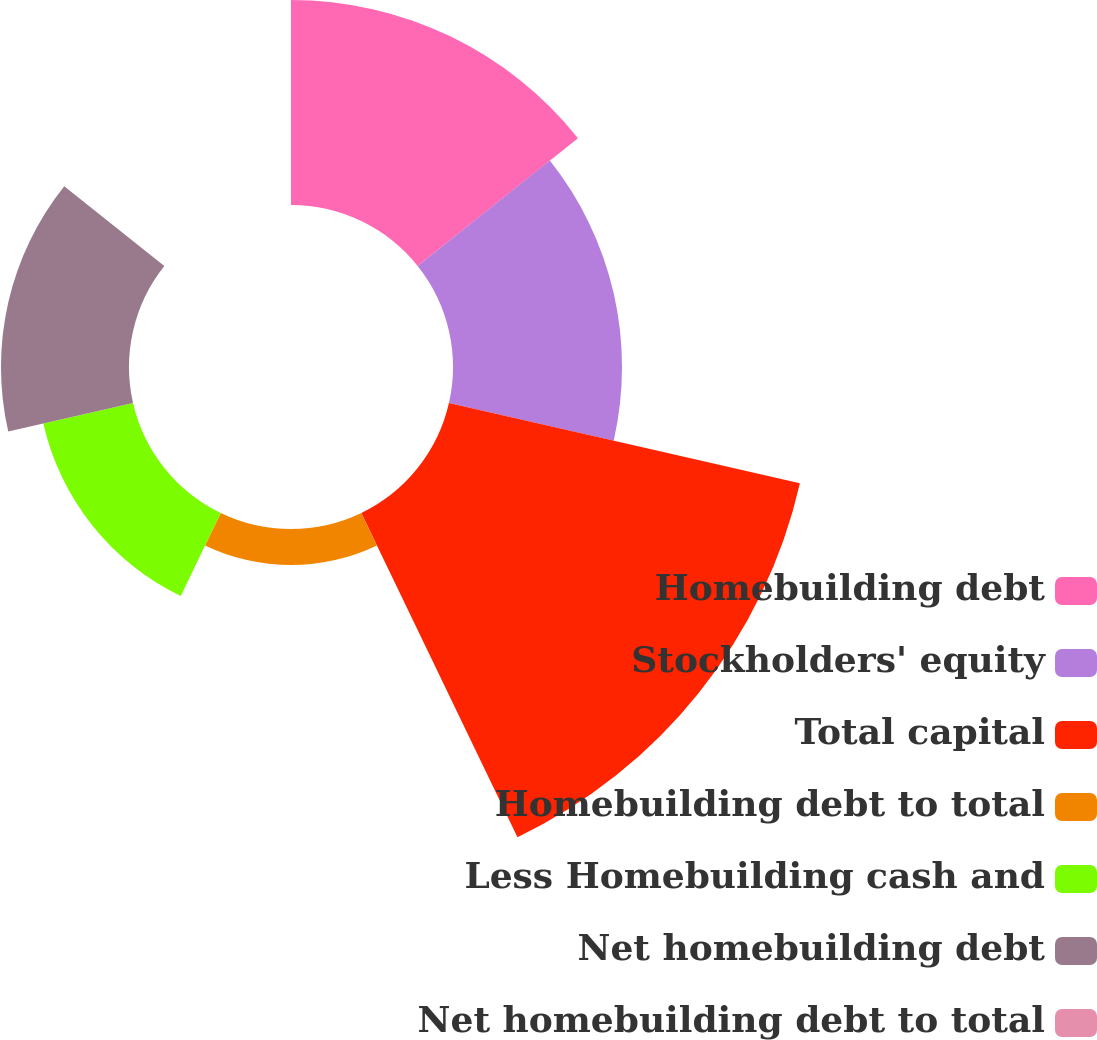Convert chart. <chart><loc_0><loc_0><loc_500><loc_500><pie_chart><fcel>Homebuilding debt<fcel>Stockholders' equity<fcel>Total capital<fcel>Homebuilding debt to total<fcel>Less Homebuilding cash and<fcel>Net homebuilding debt<fcel>Net homebuilding debt to total<nl><fcel>20.71%<fcel>17.07%<fcel>36.36%<fcel>3.64%<fcel>9.3%<fcel>12.93%<fcel>0.0%<nl></chart> 